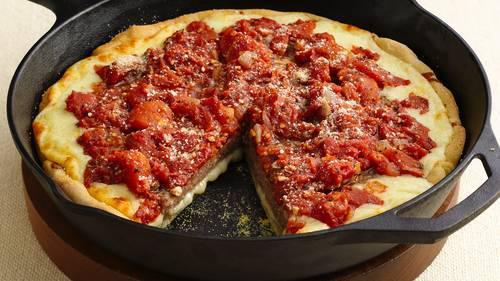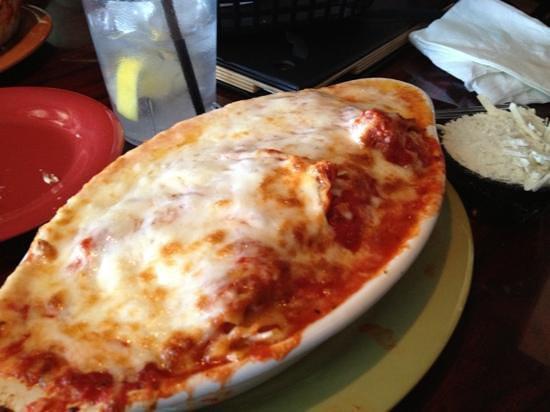The first image is the image on the left, the second image is the image on the right. Examine the images to the left and right. Is the description "In one of the images a piece of pizza pie is missing." accurate? Answer yes or no. Yes. The first image is the image on the left, the second image is the image on the right. Evaluate the accuracy of this statement regarding the images: "A wedge-shaped slice is missing from a deep-dish round 'pie' in one image.". Is it true? Answer yes or no. Yes. 